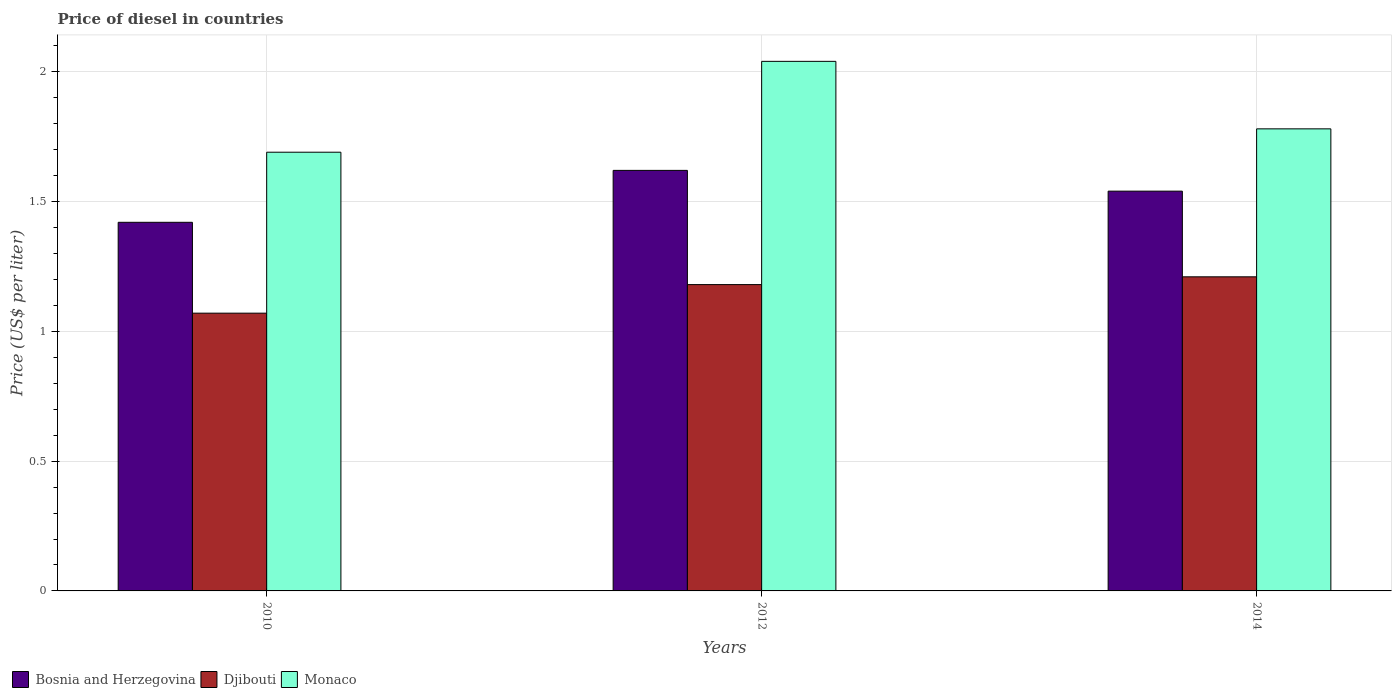How many different coloured bars are there?
Provide a succinct answer. 3. How many groups of bars are there?
Keep it short and to the point. 3. Are the number of bars on each tick of the X-axis equal?
Ensure brevity in your answer.  Yes. How many bars are there on the 3rd tick from the right?
Provide a succinct answer. 3. What is the label of the 3rd group of bars from the left?
Give a very brief answer. 2014. What is the price of diesel in Bosnia and Herzegovina in 2014?
Offer a very short reply. 1.54. Across all years, what is the maximum price of diesel in Djibouti?
Ensure brevity in your answer.  1.21. Across all years, what is the minimum price of diesel in Monaco?
Keep it short and to the point. 1.69. In which year was the price of diesel in Bosnia and Herzegovina minimum?
Provide a succinct answer. 2010. What is the total price of diesel in Monaco in the graph?
Your answer should be very brief. 5.51. What is the difference between the price of diesel in Djibouti in 2010 and that in 2014?
Keep it short and to the point. -0.14. What is the difference between the price of diesel in Djibouti in 2010 and the price of diesel in Monaco in 2014?
Your answer should be compact. -0.71. What is the average price of diesel in Monaco per year?
Your answer should be compact. 1.84. In the year 2012, what is the difference between the price of diesel in Djibouti and price of diesel in Monaco?
Ensure brevity in your answer.  -0.86. In how many years, is the price of diesel in Monaco greater than 1.1 US$?
Provide a succinct answer. 3. What is the ratio of the price of diesel in Djibouti in 2012 to that in 2014?
Provide a succinct answer. 0.98. Is the price of diesel in Bosnia and Herzegovina in 2010 less than that in 2012?
Provide a short and direct response. Yes. Is the difference between the price of diesel in Djibouti in 2010 and 2014 greater than the difference between the price of diesel in Monaco in 2010 and 2014?
Offer a very short reply. No. What is the difference between the highest and the second highest price of diesel in Bosnia and Herzegovina?
Provide a short and direct response. 0.08. What is the difference between the highest and the lowest price of diesel in Monaco?
Your answer should be compact. 0.35. In how many years, is the price of diesel in Djibouti greater than the average price of diesel in Djibouti taken over all years?
Your answer should be compact. 2. Is the sum of the price of diesel in Monaco in 2012 and 2014 greater than the maximum price of diesel in Djibouti across all years?
Give a very brief answer. Yes. What does the 1st bar from the left in 2014 represents?
Your answer should be very brief. Bosnia and Herzegovina. What does the 2nd bar from the right in 2014 represents?
Make the answer very short. Djibouti. How many bars are there?
Your response must be concise. 9. Are all the bars in the graph horizontal?
Offer a very short reply. No. Does the graph contain any zero values?
Your answer should be compact. No. Where does the legend appear in the graph?
Your answer should be compact. Bottom left. What is the title of the graph?
Make the answer very short. Price of diesel in countries. What is the label or title of the Y-axis?
Make the answer very short. Price (US$ per liter). What is the Price (US$ per liter) in Bosnia and Herzegovina in 2010?
Provide a succinct answer. 1.42. What is the Price (US$ per liter) in Djibouti in 2010?
Make the answer very short. 1.07. What is the Price (US$ per liter) in Monaco in 2010?
Keep it short and to the point. 1.69. What is the Price (US$ per liter) in Bosnia and Herzegovina in 2012?
Make the answer very short. 1.62. What is the Price (US$ per liter) in Djibouti in 2012?
Keep it short and to the point. 1.18. What is the Price (US$ per liter) of Monaco in 2012?
Provide a succinct answer. 2.04. What is the Price (US$ per liter) of Bosnia and Herzegovina in 2014?
Offer a terse response. 1.54. What is the Price (US$ per liter) of Djibouti in 2014?
Give a very brief answer. 1.21. What is the Price (US$ per liter) of Monaco in 2014?
Keep it short and to the point. 1.78. Across all years, what is the maximum Price (US$ per liter) in Bosnia and Herzegovina?
Make the answer very short. 1.62. Across all years, what is the maximum Price (US$ per liter) of Djibouti?
Make the answer very short. 1.21. Across all years, what is the maximum Price (US$ per liter) of Monaco?
Your answer should be compact. 2.04. Across all years, what is the minimum Price (US$ per liter) of Bosnia and Herzegovina?
Your response must be concise. 1.42. Across all years, what is the minimum Price (US$ per liter) in Djibouti?
Make the answer very short. 1.07. Across all years, what is the minimum Price (US$ per liter) of Monaco?
Offer a very short reply. 1.69. What is the total Price (US$ per liter) of Bosnia and Herzegovina in the graph?
Offer a terse response. 4.58. What is the total Price (US$ per liter) in Djibouti in the graph?
Offer a terse response. 3.46. What is the total Price (US$ per liter) of Monaco in the graph?
Your answer should be compact. 5.51. What is the difference between the Price (US$ per liter) in Djibouti in 2010 and that in 2012?
Your answer should be very brief. -0.11. What is the difference between the Price (US$ per liter) in Monaco in 2010 and that in 2012?
Ensure brevity in your answer.  -0.35. What is the difference between the Price (US$ per liter) in Bosnia and Herzegovina in 2010 and that in 2014?
Your answer should be compact. -0.12. What is the difference between the Price (US$ per liter) of Djibouti in 2010 and that in 2014?
Offer a very short reply. -0.14. What is the difference between the Price (US$ per liter) in Monaco in 2010 and that in 2014?
Make the answer very short. -0.09. What is the difference between the Price (US$ per liter) of Bosnia and Herzegovina in 2012 and that in 2014?
Your answer should be compact. 0.08. What is the difference between the Price (US$ per liter) of Djibouti in 2012 and that in 2014?
Offer a very short reply. -0.03. What is the difference between the Price (US$ per liter) of Monaco in 2012 and that in 2014?
Provide a succinct answer. 0.26. What is the difference between the Price (US$ per liter) of Bosnia and Herzegovina in 2010 and the Price (US$ per liter) of Djibouti in 2012?
Offer a very short reply. 0.24. What is the difference between the Price (US$ per liter) in Bosnia and Herzegovina in 2010 and the Price (US$ per liter) in Monaco in 2012?
Offer a terse response. -0.62. What is the difference between the Price (US$ per liter) of Djibouti in 2010 and the Price (US$ per liter) of Monaco in 2012?
Give a very brief answer. -0.97. What is the difference between the Price (US$ per liter) of Bosnia and Herzegovina in 2010 and the Price (US$ per liter) of Djibouti in 2014?
Your answer should be very brief. 0.21. What is the difference between the Price (US$ per liter) in Bosnia and Herzegovina in 2010 and the Price (US$ per liter) in Monaco in 2014?
Make the answer very short. -0.36. What is the difference between the Price (US$ per liter) of Djibouti in 2010 and the Price (US$ per liter) of Monaco in 2014?
Your response must be concise. -0.71. What is the difference between the Price (US$ per liter) of Bosnia and Herzegovina in 2012 and the Price (US$ per liter) of Djibouti in 2014?
Make the answer very short. 0.41. What is the difference between the Price (US$ per liter) in Bosnia and Herzegovina in 2012 and the Price (US$ per liter) in Monaco in 2014?
Offer a terse response. -0.16. What is the difference between the Price (US$ per liter) of Djibouti in 2012 and the Price (US$ per liter) of Monaco in 2014?
Give a very brief answer. -0.6. What is the average Price (US$ per liter) in Bosnia and Herzegovina per year?
Offer a terse response. 1.53. What is the average Price (US$ per liter) in Djibouti per year?
Ensure brevity in your answer.  1.15. What is the average Price (US$ per liter) in Monaco per year?
Provide a succinct answer. 1.84. In the year 2010, what is the difference between the Price (US$ per liter) in Bosnia and Herzegovina and Price (US$ per liter) in Djibouti?
Give a very brief answer. 0.35. In the year 2010, what is the difference between the Price (US$ per liter) of Bosnia and Herzegovina and Price (US$ per liter) of Monaco?
Keep it short and to the point. -0.27. In the year 2010, what is the difference between the Price (US$ per liter) in Djibouti and Price (US$ per liter) in Monaco?
Provide a short and direct response. -0.62. In the year 2012, what is the difference between the Price (US$ per liter) of Bosnia and Herzegovina and Price (US$ per liter) of Djibouti?
Provide a succinct answer. 0.44. In the year 2012, what is the difference between the Price (US$ per liter) of Bosnia and Herzegovina and Price (US$ per liter) of Monaco?
Offer a very short reply. -0.42. In the year 2012, what is the difference between the Price (US$ per liter) in Djibouti and Price (US$ per liter) in Monaco?
Ensure brevity in your answer.  -0.86. In the year 2014, what is the difference between the Price (US$ per liter) of Bosnia and Herzegovina and Price (US$ per liter) of Djibouti?
Ensure brevity in your answer.  0.33. In the year 2014, what is the difference between the Price (US$ per liter) of Bosnia and Herzegovina and Price (US$ per liter) of Monaco?
Ensure brevity in your answer.  -0.24. In the year 2014, what is the difference between the Price (US$ per liter) of Djibouti and Price (US$ per liter) of Monaco?
Offer a terse response. -0.57. What is the ratio of the Price (US$ per liter) in Bosnia and Herzegovina in 2010 to that in 2012?
Make the answer very short. 0.88. What is the ratio of the Price (US$ per liter) in Djibouti in 2010 to that in 2012?
Offer a very short reply. 0.91. What is the ratio of the Price (US$ per liter) in Monaco in 2010 to that in 2012?
Your answer should be very brief. 0.83. What is the ratio of the Price (US$ per liter) of Bosnia and Herzegovina in 2010 to that in 2014?
Offer a terse response. 0.92. What is the ratio of the Price (US$ per liter) of Djibouti in 2010 to that in 2014?
Provide a succinct answer. 0.88. What is the ratio of the Price (US$ per liter) of Monaco in 2010 to that in 2014?
Keep it short and to the point. 0.95. What is the ratio of the Price (US$ per liter) in Bosnia and Herzegovina in 2012 to that in 2014?
Offer a terse response. 1.05. What is the ratio of the Price (US$ per liter) of Djibouti in 2012 to that in 2014?
Give a very brief answer. 0.98. What is the ratio of the Price (US$ per liter) of Monaco in 2012 to that in 2014?
Provide a succinct answer. 1.15. What is the difference between the highest and the second highest Price (US$ per liter) of Monaco?
Provide a short and direct response. 0.26. What is the difference between the highest and the lowest Price (US$ per liter) in Djibouti?
Your answer should be compact. 0.14. 